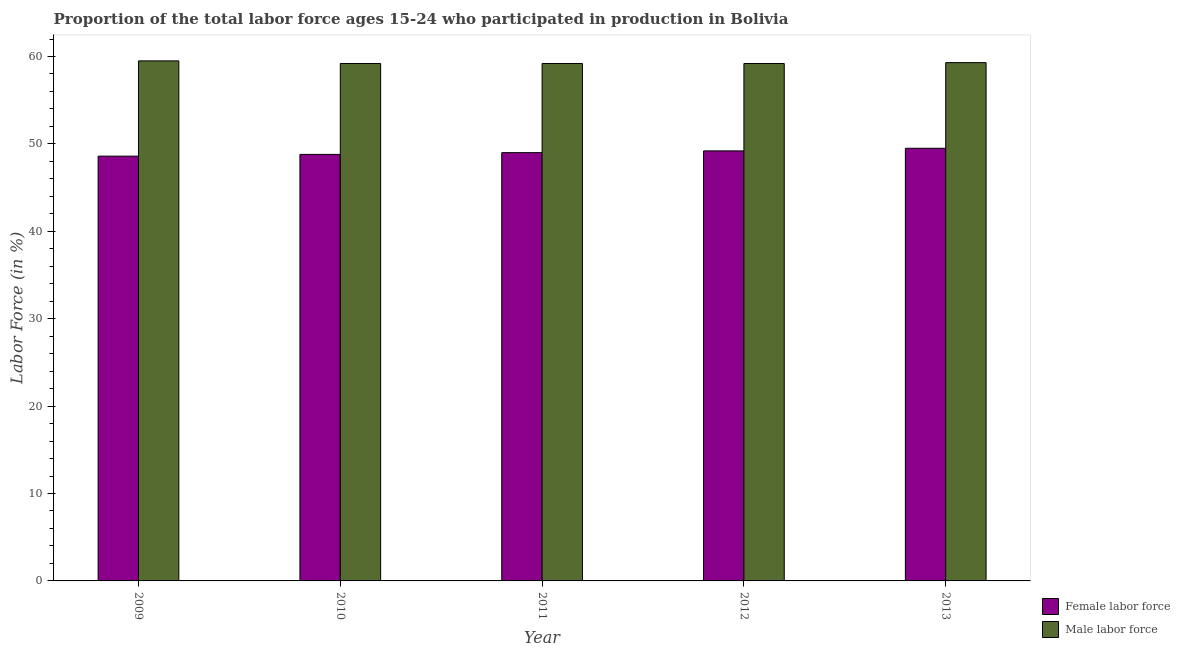What is the label of the 3rd group of bars from the left?
Ensure brevity in your answer.  2011. In how many cases, is the number of bars for a given year not equal to the number of legend labels?
Keep it short and to the point. 0. What is the percentage of male labour force in 2012?
Offer a very short reply. 59.2. Across all years, what is the maximum percentage of male labour force?
Your answer should be very brief. 59.5. Across all years, what is the minimum percentage of female labor force?
Provide a short and direct response. 48.6. In which year was the percentage of male labour force maximum?
Provide a short and direct response. 2009. What is the total percentage of male labour force in the graph?
Offer a very short reply. 296.4. What is the difference between the percentage of male labour force in 2012 and that in 2013?
Your response must be concise. -0.1. What is the difference between the percentage of female labor force in 2010 and the percentage of male labour force in 2009?
Provide a succinct answer. 0.2. What is the average percentage of female labor force per year?
Your answer should be very brief. 49.02. In the year 2013, what is the difference between the percentage of female labor force and percentage of male labour force?
Make the answer very short. 0. What is the ratio of the percentage of female labor force in 2009 to that in 2013?
Ensure brevity in your answer.  0.98. Is the percentage of male labour force in 2011 less than that in 2013?
Your answer should be very brief. Yes. What is the difference between the highest and the second highest percentage of female labor force?
Keep it short and to the point. 0.3. What is the difference between the highest and the lowest percentage of male labour force?
Your response must be concise. 0.3. In how many years, is the percentage of male labour force greater than the average percentage of male labour force taken over all years?
Make the answer very short. 2. Is the sum of the percentage of female labor force in 2009 and 2013 greater than the maximum percentage of male labour force across all years?
Provide a succinct answer. Yes. What does the 1st bar from the left in 2012 represents?
Provide a short and direct response. Female labor force. What does the 1st bar from the right in 2013 represents?
Your answer should be very brief. Male labor force. How many bars are there?
Your answer should be compact. 10. Are all the bars in the graph horizontal?
Give a very brief answer. No. How many years are there in the graph?
Ensure brevity in your answer.  5. What is the difference between two consecutive major ticks on the Y-axis?
Offer a terse response. 10. Where does the legend appear in the graph?
Offer a terse response. Bottom right. What is the title of the graph?
Make the answer very short. Proportion of the total labor force ages 15-24 who participated in production in Bolivia. What is the label or title of the X-axis?
Keep it short and to the point. Year. What is the Labor Force (in %) in Female labor force in 2009?
Provide a short and direct response. 48.6. What is the Labor Force (in %) of Male labor force in 2009?
Keep it short and to the point. 59.5. What is the Labor Force (in %) of Female labor force in 2010?
Provide a succinct answer. 48.8. What is the Labor Force (in %) in Male labor force in 2010?
Give a very brief answer. 59.2. What is the Labor Force (in %) in Female labor force in 2011?
Give a very brief answer. 49. What is the Labor Force (in %) of Male labor force in 2011?
Keep it short and to the point. 59.2. What is the Labor Force (in %) in Female labor force in 2012?
Your response must be concise. 49.2. What is the Labor Force (in %) in Male labor force in 2012?
Provide a short and direct response. 59.2. What is the Labor Force (in %) in Female labor force in 2013?
Your response must be concise. 49.5. What is the Labor Force (in %) of Male labor force in 2013?
Offer a terse response. 59.3. Across all years, what is the maximum Labor Force (in %) in Female labor force?
Ensure brevity in your answer.  49.5. Across all years, what is the maximum Labor Force (in %) in Male labor force?
Your answer should be very brief. 59.5. Across all years, what is the minimum Labor Force (in %) of Female labor force?
Provide a short and direct response. 48.6. Across all years, what is the minimum Labor Force (in %) of Male labor force?
Make the answer very short. 59.2. What is the total Labor Force (in %) of Female labor force in the graph?
Offer a very short reply. 245.1. What is the total Labor Force (in %) in Male labor force in the graph?
Keep it short and to the point. 296.4. What is the difference between the Labor Force (in %) in Female labor force in 2009 and that in 2011?
Ensure brevity in your answer.  -0.4. What is the difference between the Labor Force (in %) in Male labor force in 2009 and that in 2012?
Provide a succinct answer. 0.3. What is the difference between the Labor Force (in %) in Female labor force in 2010 and that in 2011?
Ensure brevity in your answer.  -0.2. What is the difference between the Labor Force (in %) of Male labor force in 2010 and that in 2011?
Give a very brief answer. 0. What is the difference between the Labor Force (in %) in Female labor force in 2010 and that in 2013?
Offer a terse response. -0.7. What is the difference between the Labor Force (in %) of Male labor force in 2010 and that in 2013?
Provide a succinct answer. -0.1. What is the difference between the Labor Force (in %) in Female labor force in 2011 and that in 2012?
Ensure brevity in your answer.  -0.2. What is the difference between the Labor Force (in %) in Male labor force in 2012 and that in 2013?
Offer a terse response. -0.1. What is the difference between the Labor Force (in %) of Female labor force in 2009 and the Labor Force (in %) of Male labor force in 2011?
Your answer should be compact. -10.6. What is the difference between the Labor Force (in %) of Female labor force in 2009 and the Labor Force (in %) of Male labor force in 2012?
Provide a short and direct response. -10.6. What is the difference between the Labor Force (in %) in Female labor force in 2009 and the Labor Force (in %) in Male labor force in 2013?
Your answer should be very brief. -10.7. What is the difference between the Labor Force (in %) of Female labor force in 2010 and the Labor Force (in %) of Male labor force in 2011?
Your response must be concise. -10.4. What is the difference between the Labor Force (in %) in Female labor force in 2010 and the Labor Force (in %) in Male labor force in 2013?
Ensure brevity in your answer.  -10.5. What is the difference between the Labor Force (in %) in Female labor force in 2011 and the Labor Force (in %) in Male labor force in 2012?
Keep it short and to the point. -10.2. What is the average Labor Force (in %) of Female labor force per year?
Your answer should be very brief. 49.02. What is the average Labor Force (in %) in Male labor force per year?
Offer a terse response. 59.28. In the year 2009, what is the difference between the Labor Force (in %) in Female labor force and Labor Force (in %) in Male labor force?
Provide a short and direct response. -10.9. In the year 2011, what is the difference between the Labor Force (in %) in Female labor force and Labor Force (in %) in Male labor force?
Your response must be concise. -10.2. In the year 2012, what is the difference between the Labor Force (in %) of Female labor force and Labor Force (in %) of Male labor force?
Keep it short and to the point. -10. In the year 2013, what is the difference between the Labor Force (in %) in Female labor force and Labor Force (in %) in Male labor force?
Offer a very short reply. -9.8. What is the ratio of the Labor Force (in %) in Male labor force in 2009 to that in 2011?
Your answer should be compact. 1.01. What is the ratio of the Labor Force (in %) in Male labor force in 2009 to that in 2012?
Provide a succinct answer. 1.01. What is the ratio of the Labor Force (in %) in Female labor force in 2009 to that in 2013?
Ensure brevity in your answer.  0.98. What is the ratio of the Labor Force (in %) in Male labor force in 2010 to that in 2011?
Make the answer very short. 1. What is the ratio of the Labor Force (in %) of Female labor force in 2010 to that in 2012?
Offer a very short reply. 0.99. What is the ratio of the Labor Force (in %) of Male labor force in 2010 to that in 2012?
Your answer should be compact. 1. What is the ratio of the Labor Force (in %) of Female labor force in 2010 to that in 2013?
Your response must be concise. 0.99. What is the ratio of the Labor Force (in %) of Male labor force in 2011 to that in 2012?
Your answer should be compact. 1. What is the ratio of the Labor Force (in %) of Female labor force in 2012 to that in 2013?
Your answer should be compact. 0.99. What is the ratio of the Labor Force (in %) of Male labor force in 2012 to that in 2013?
Make the answer very short. 1. What is the difference between the highest and the lowest Labor Force (in %) in Female labor force?
Ensure brevity in your answer.  0.9. What is the difference between the highest and the lowest Labor Force (in %) in Male labor force?
Provide a short and direct response. 0.3. 